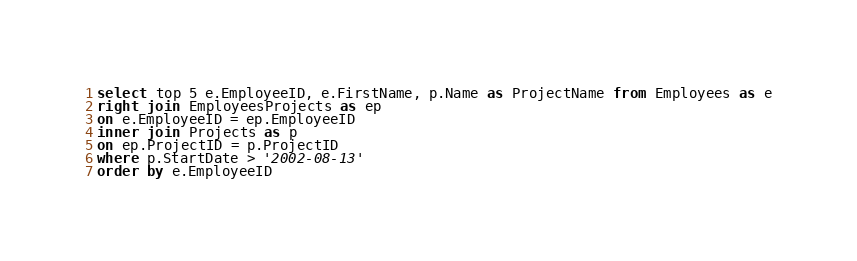Convert code to text. <code><loc_0><loc_0><loc_500><loc_500><_SQL_>select top 5 e.EmployeeID, e.FirstName, p.Name as ProjectName from Employees as e
right join EmployeesProjects as ep
on e.EmployeeID = ep.EmployeeID
inner join Projects as p
on ep.ProjectID = p.ProjectID
where p.StartDate > '2002-08-13'
order by e.EmployeeID</code> 